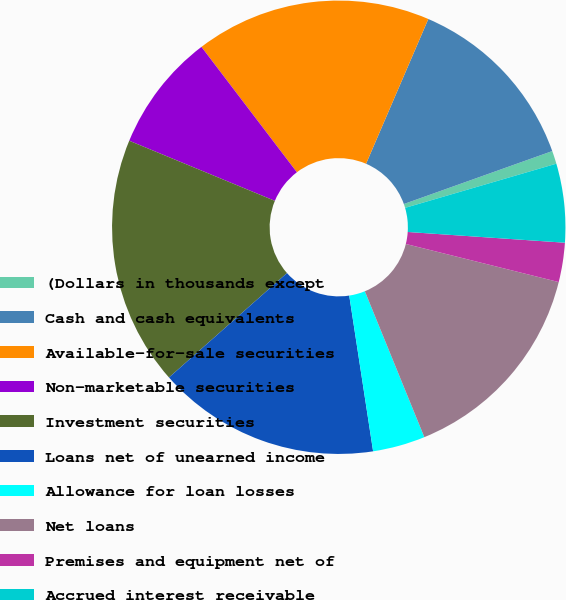Convert chart to OTSL. <chart><loc_0><loc_0><loc_500><loc_500><pie_chart><fcel>(Dollars in thousands except<fcel>Cash and cash equivalents<fcel>Available-for-sale securities<fcel>Non-marketable securities<fcel>Investment securities<fcel>Loans net of unearned income<fcel>Allowance for loan losses<fcel>Net loans<fcel>Premises and equipment net of<fcel>Accrued interest receivable<nl><fcel>0.93%<fcel>13.08%<fcel>16.82%<fcel>8.41%<fcel>17.76%<fcel>15.89%<fcel>3.74%<fcel>14.95%<fcel>2.8%<fcel>5.61%<nl></chart> 